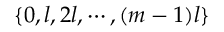Convert formula to latex. <formula><loc_0><loc_0><loc_500><loc_500>\{ 0 , l , 2 l , \cdots , ( m - 1 ) l \}</formula> 